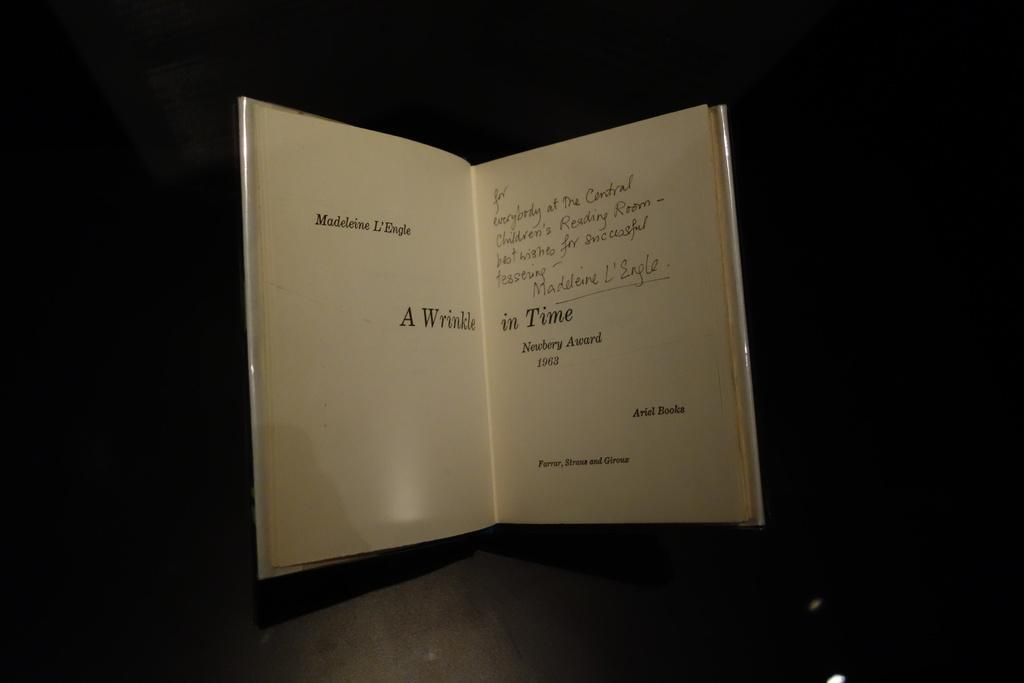<image>
Render a clear and concise summary of the photo. A book, A Wrinkle in Time, is opened, standing up on a table. 